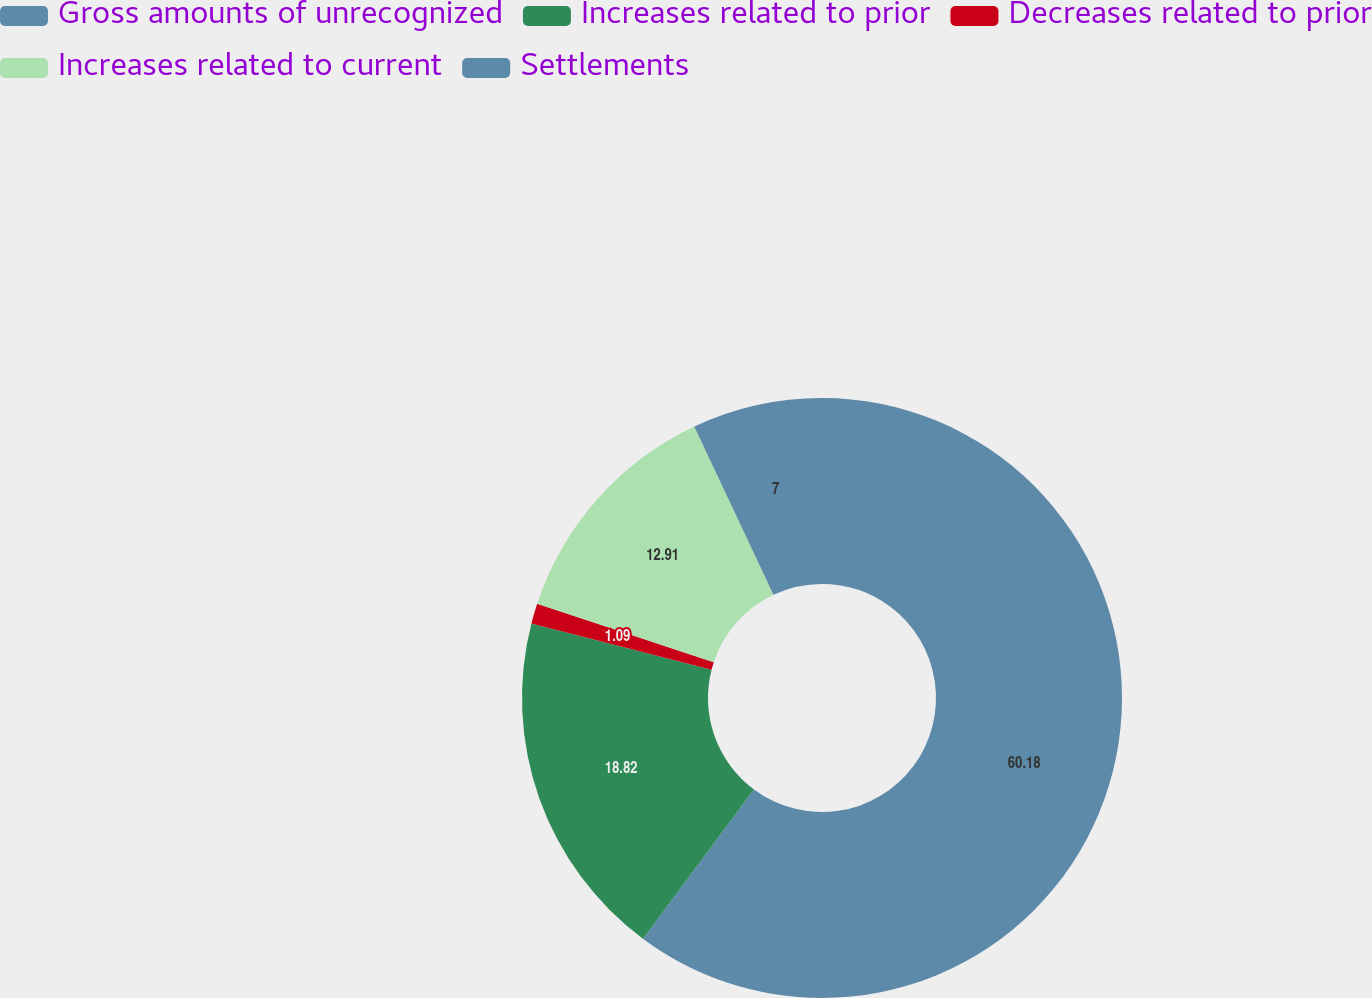Convert chart to OTSL. <chart><loc_0><loc_0><loc_500><loc_500><pie_chart><fcel>Gross amounts of unrecognized<fcel>Increases related to prior<fcel>Decreases related to prior<fcel>Increases related to current<fcel>Settlements<nl><fcel>60.18%<fcel>18.82%<fcel>1.09%<fcel>12.91%<fcel>7.0%<nl></chart> 